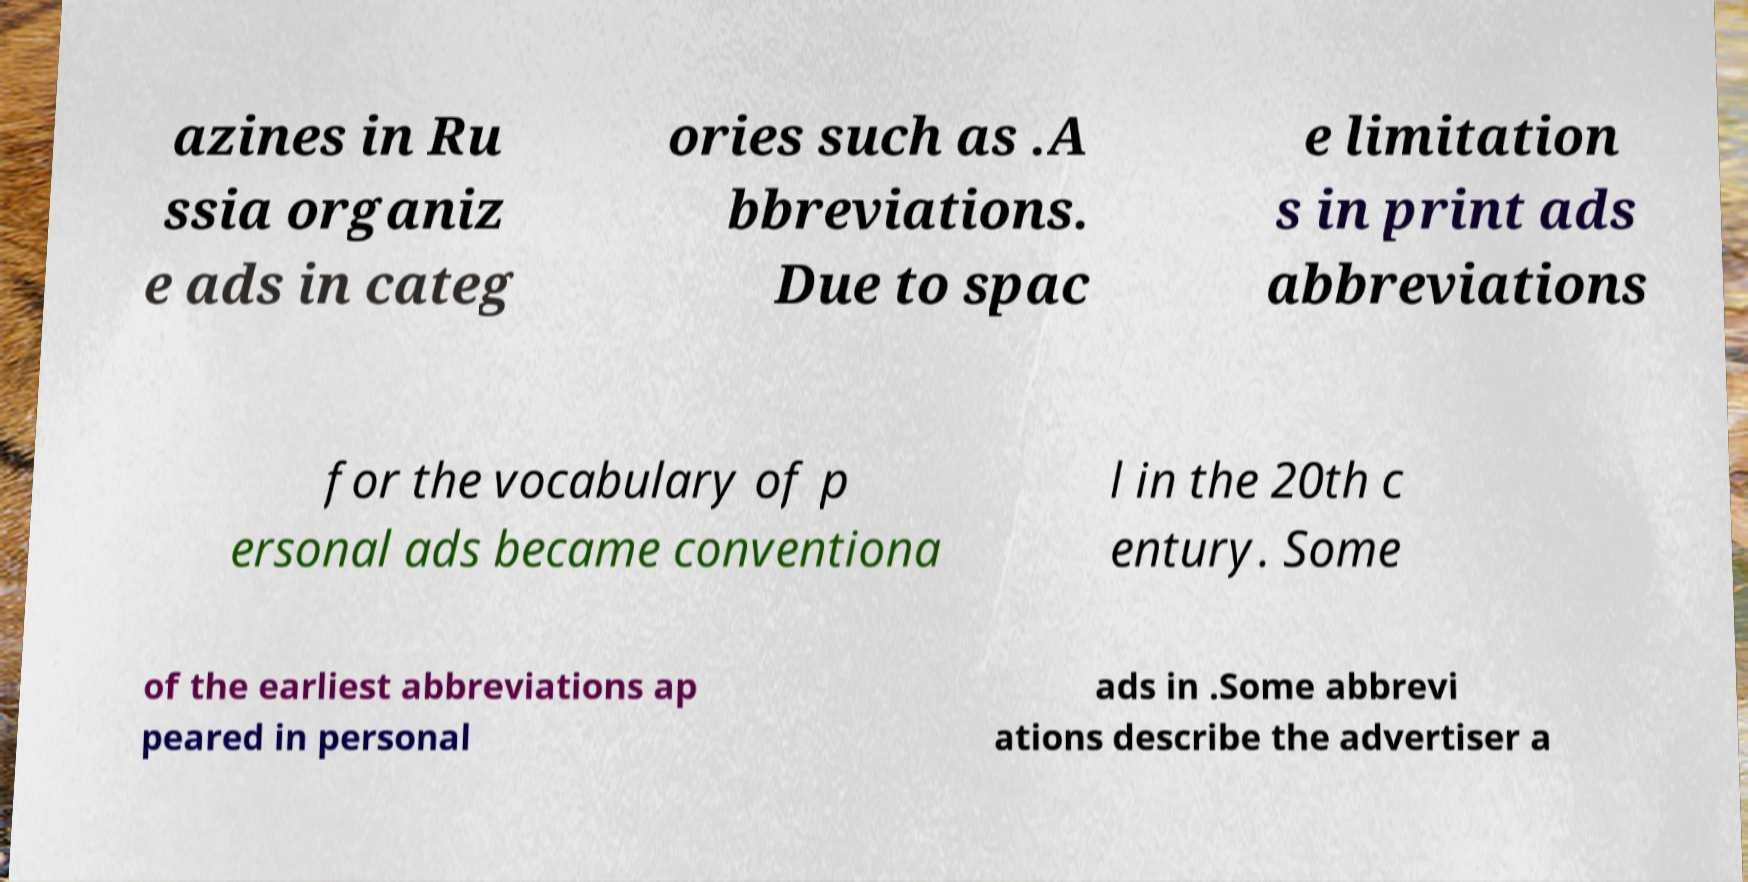What messages or text are displayed in this image? I need them in a readable, typed format. azines in Ru ssia organiz e ads in categ ories such as .A bbreviations. Due to spac e limitation s in print ads abbreviations for the vocabulary of p ersonal ads became conventiona l in the 20th c entury. Some of the earliest abbreviations ap peared in personal ads in .Some abbrevi ations describe the advertiser a 